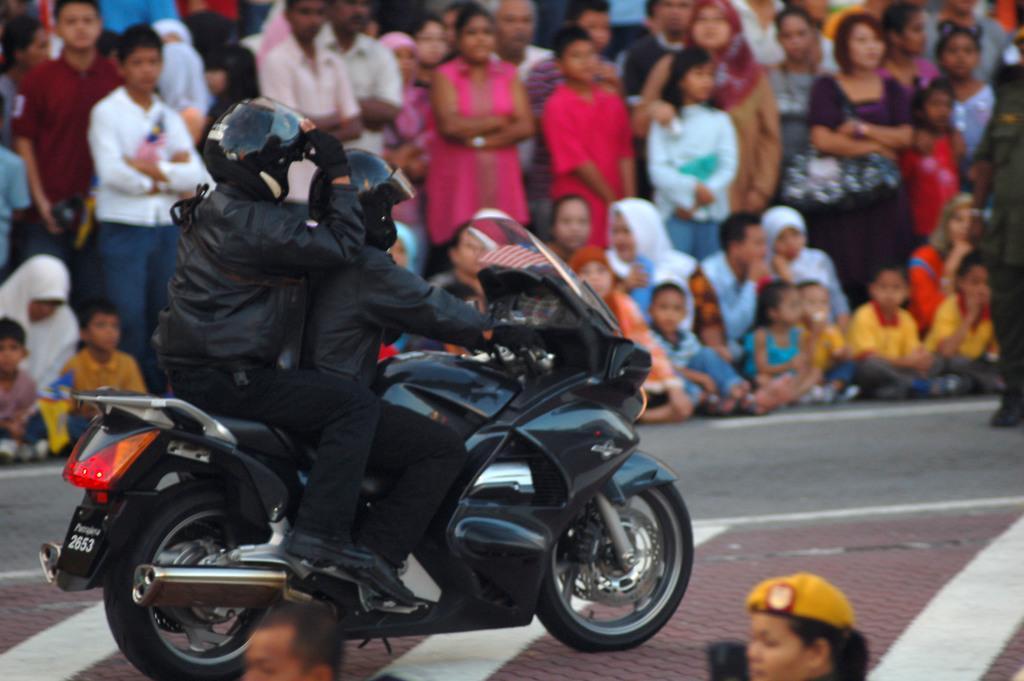Please provide a concise description of this image. There are two persons wearing black dress sitting on a black bike and there are audience beside them. 